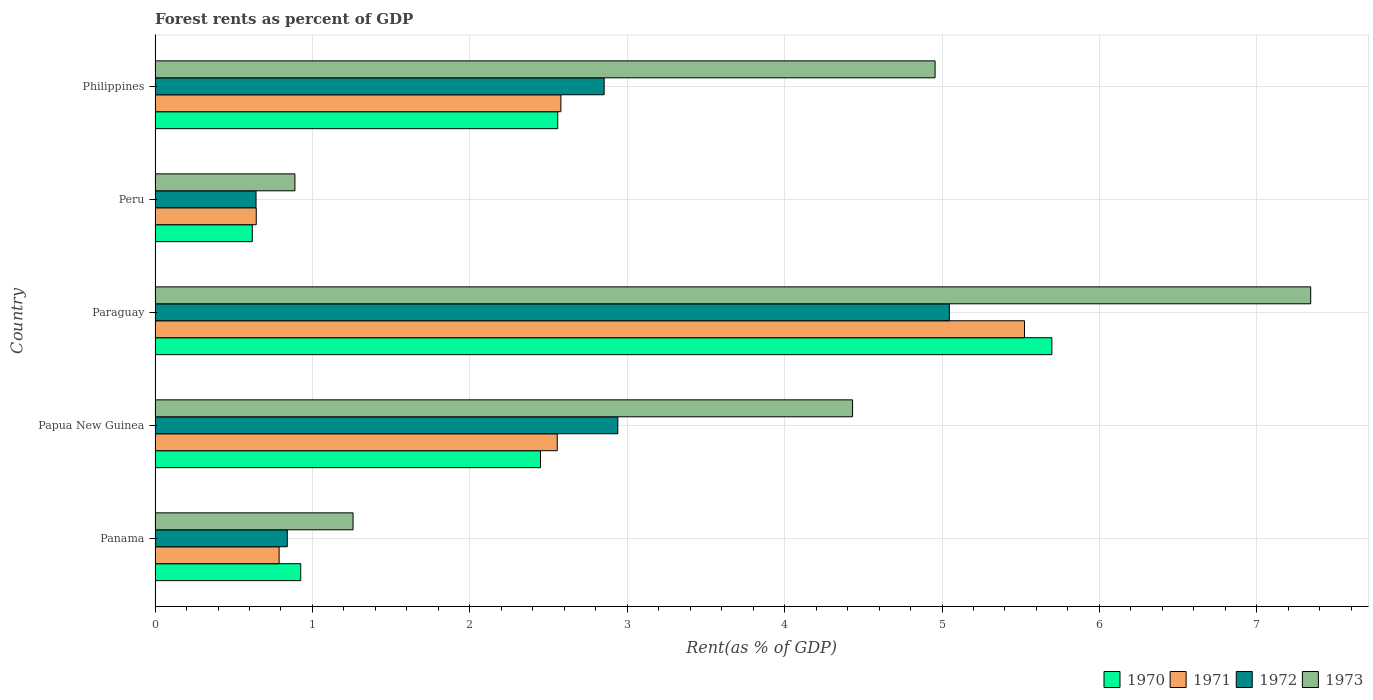How many different coloured bars are there?
Your answer should be very brief. 4. Are the number of bars per tick equal to the number of legend labels?
Offer a very short reply. Yes. How many bars are there on the 3rd tick from the top?
Your answer should be very brief. 4. How many bars are there on the 1st tick from the bottom?
Give a very brief answer. 4. What is the label of the 5th group of bars from the top?
Offer a very short reply. Panama. What is the forest rent in 1972 in Peru?
Provide a succinct answer. 0.64. Across all countries, what is the maximum forest rent in 1970?
Give a very brief answer. 5.7. Across all countries, what is the minimum forest rent in 1972?
Ensure brevity in your answer.  0.64. In which country was the forest rent in 1972 maximum?
Ensure brevity in your answer.  Paraguay. What is the total forest rent in 1971 in the graph?
Give a very brief answer. 12.09. What is the difference between the forest rent in 1970 in Paraguay and that in Peru?
Your answer should be very brief. 5.08. What is the difference between the forest rent in 1972 in Papua New Guinea and the forest rent in 1970 in Philippines?
Your response must be concise. 0.38. What is the average forest rent in 1970 per country?
Your answer should be very brief. 2.45. What is the difference between the forest rent in 1971 and forest rent in 1973 in Papua New Guinea?
Your answer should be compact. -1.88. What is the ratio of the forest rent in 1970 in Papua New Guinea to that in Philippines?
Provide a short and direct response. 0.96. What is the difference between the highest and the second highest forest rent in 1970?
Make the answer very short. 3.14. What is the difference between the highest and the lowest forest rent in 1970?
Give a very brief answer. 5.08. In how many countries, is the forest rent in 1970 greater than the average forest rent in 1970 taken over all countries?
Provide a succinct answer. 2. Is it the case that in every country, the sum of the forest rent in 1971 and forest rent in 1973 is greater than the forest rent in 1972?
Ensure brevity in your answer.  Yes. How many countries are there in the graph?
Provide a short and direct response. 5. How many legend labels are there?
Provide a short and direct response. 4. How are the legend labels stacked?
Make the answer very short. Horizontal. What is the title of the graph?
Your answer should be very brief. Forest rents as percent of GDP. Does "1986" appear as one of the legend labels in the graph?
Your answer should be compact. No. What is the label or title of the X-axis?
Offer a terse response. Rent(as % of GDP). What is the label or title of the Y-axis?
Ensure brevity in your answer.  Country. What is the Rent(as % of GDP) in 1970 in Panama?
Provide a succinct answer. 0.93. What is the Rent(as % of GDP) in 1971 in Panama?
Offer a terse response. 0.79. What is the Rent(as % of GDP) of 1972 in Panama?
Provide a succinct answer. 0.84. What is the Rent(as % of GDP) of 1973 in Panama?
Offer a very short reply. 1.26. What is the Rent(as % of GDP) in 1970 in Papua New Guinea?
Give a very brief answer. 2.45. What is the Rent(as % of GDP) in 1971 in Papua New Guinea?
Give a very brief answer. 2.56. What is the Rent(as % of GDP) in 1972 in Papua New Guinea?
Make the answer very short. 2.94. What is the Rent(as % of GDP) of 1973 in Papua New Guinea?
Offer a very short reply. 4.43. What is the Rent(as % of GDP) in 1970 in Paraguay?
Keep it short and to the point. 5.7. What is the Rent(as % of GDP) in 1971 in Paraguay?
Offer a very short reply. 5.52. What is the Rent(as % of GDP) in 1972 in Paraguay?
Give a very brief answer. 5.05. What is the Rent(as % of GDP) in 1973 in Paraguay?
Offer a very short reply. 7.34. What is the Rent(as % of GDP) in 1970 in Peru?
Your answer should be compact. 0.62. What is the Rent(as % of GDP) of 1971 in Peru?
Ensure brevity in your answer.  0.64. What is the Rent(as % of GDP) in 1972 in Peru?
Your answer should be very brief. 0.64. What is the Rent(as % of GDP) of 1973 in Peru?
Your answer should be very brief. 0.89. What is the Rent(as % of GDP) of 1970 in Philippines?
Keep it short and to the point. 2.56. What is the Rent(as % of GDP) of 1971 in Philippines?
Your answer should be very brief. 2.58. What is the Rent(as % of GDP) of 1972 in Philippines?
Offer a very short reply. 2.85. What is the Rent(as % of GDP) of 1973 in Philippines?
Give a very brief answer. 4.96. Across all countries, what is the maximum Rent(as % of GDP) in 1970?
Offer a terse response. 5.7. Across all countries, what is the maximum Rent(as % of GDP) in 1971?
Your answer should be compact. 5.52. Across all countries, what is the maximum Rent(as % of GDP) in 1972?
Ensure brevity in your answer.  5.05. Across all countries, what is the maximum Rent(as % of GDP) of 1973?
Your response must be concise. 7.34. Across all countries, what is the minimum Rent(as % of GDP) of 1970?
Offer a very short reply. 0.62. Across all countries, what is the minimum Rent(as % of GDP) in 1971?
Your answer should be compact. 0.64. Across all countries, what is the minimum Rent(as % of GDP) in 1972?
Your answer should be compact. 0.64. Across all countries, what is the minimum Rent(as % of GDP) in 1973?
Make the answer very short. 0.89. What is the total Rent(as % of GDP) of 1970 in the graph?
Provide a succinct answer. 12.25. What is the total Rent(as % of GDP) of 1971 in the graph?
Offer a terse response. 12.09. What is the total Rent(as % of GDP) of 1972 in the graph?
Offer a terse response. 12.32. What is the total Rent(as % of GDP) of 1973 in the graph?
Your response must be concise. 18.88. What is the difference between the Rent(as % of GDP) in 1970 in Panama and that in Papua New Guinea?
Provide a succinct answer. -1.52. What is the difference between the Rent(as % of GDP) in 1971 in Panama and that in Papua New Guinea?
Your answer should be compact. -1.77. What is the difference between the Rent(as % of GDP) in 1973 in Panama and that in Papua New Guinea?
Offer a terse response. -3.17. What is the difference between the Rent(as % of GDP) in 1970 in Panama and that in Paraguay?
Make the answer very short. -4.77. What is the difference between the Rent(as % of GDP) in 1971 in Panama and that in Paraguay?
Provide a short and direct response. -4.74. What is the difference between the Rent(as % of GDP) in 1972 in Panama and that in Paraguay?
Ensure brevity in your answer.  -4.21. What is the difference between the Rent(as % of GDP) in 1973 in Panama and that in Paraguay?
Provide a succinct answer. -6.08. What is the difference between the Rent(as % of GDP) in 1970 in Panama and that in Peru?
Provide a short and direct response. 0.31. What is the difference between the Rent(as % of GDP) of 1971 in Panama and that in Peru?
Offer a very short reply. 0.15. What is the difference between the Rent(as % of GDP) of 1972 in Panama and that in Peru?
Keep it short and to the point. 0.2. What is the difference between the Rent(as % of GDP) in 1973 in Panama and that in Peru?
Your response must be concise. 0.37. What is the difference between the Rent(as % of GDP) in 1970 in Panama and that in Philippines?
Keep it short and to the point. -1.63. What is the difference between the Rent(as % of GDP) of 1971 in Panama and that in Philippines?
Your response must be concise. -1.79. What is the difference between the Rent(as % of GDP) in 1972 in Panama and that in Philippines?
Keep it short and to the point. -2.01. What is the difference between the Rent(as % of GDP) in 1973 in Panama and that in Philippines?
Provide a short and direct response. -3.7. What is the difference between the Rent(as % of GDP) in 1970 in Papua New Guinea and that in Paraguay?
Make the answer very short. -3.25. What is the difference between the Rent(as % of GDP) in 1971 in Papua New Guinea and that in Paraguay?
Offer a terse response. -2.97. What is the difference between the Rent(as % of GDP) in 1972 in Papua New Guinea and that in Paraguay?
Your response must be concise. -2.11. What is the difference between the Rent(as % of GDP) of 1973 in Papua New Guinea and that in Paraguay?
Ensure brevity in your answer.  -2.91. What is the difference between the Rent(as % of GDP) in 1970 in Papua New Guinea and that in Peru?
Keep it short and to the point. 1.83. What is the difference between the Rent(as % of GDP) in 1971 in Papua New Guinea and that in Peru?
Your answer should be compact. 1.91. What is the difference between the Rent(as % of GDP) of 1972 in Papua New Guinea and that in Peru?
Keep it short and to the point. 2.3. What is the difference between the Rent(as % of GDP) in 1973 in Papua New Guinea and that in Peru?
Provide a short and direct response. 3.54. What is the difference between the Rent(as % of GDP) in 1970 in Papua New Guinea and that in Philippines?
Your response must be concise. -0.11. What is the difference between the Rent(as % of GDP) of 1971 in Papua New Guinea and that in Philippines?
Your response must be concise. -0.02. What is the difference between the Rent(as % of GDP) of 1972 in Papua New Guinea and that in Philippines?
Provide a short and direct response. 0.09. What is the difference between the Rent(as % of GDP) in 1973 in Papua New Guinea and that in Philippines?
Give a very brief answer. -0.52. What is the difference between the Rent(as % of GDP) in 1970 in Paraguay and that in Peru?
Offer a very short reply. 5.08. What is the difference between the Rent(as % of GDP) of 1971 in Paraguay and that in Peru?
Your answer should be compact. 4.88. What is the difference between the Rent(as % of GDP) in 1972 in Paraguay and that in Peru?
Provide a succinct answer. 4.41. What is the difference between the Rent(as % of GDP) in 1973 in Paraguay and that in Peru?
Provide a short and direct response. 6.45. What is the difference between the Rent(as % of GDP) of 1970 in Paraguay and that in Philippines?
Provide a succinct answer. 3.14. What is the difference between the Rent(as % of GDP) of 1971 in Paraguay and that in Philippines?
Give a very brief answer. 2.95. What is the difference between the Rent(as % of GDP) in 1972 in Paraguay and that in Philippines?
Offer a terse response. 2.19. What is the difference between the Rent(as % of GDP) of 1973 in Paraguay and that in Philippines?
Give a very brief answer. 2.39. What is the difference between the Rent(as % of GDP) of 1970 in Peru and that in Philippines?
Your answer should be compact. -1.94. What is the difference between the Rent(as % of GDP) of 1971 in Peru and that in Philippines?
Your response must be concise. -1.94. What is the difference between the Rent(as % of GDP) of 1972 in Peru and that in Philippines?
Give a very brief answer. -2.21. What is the difference between the Rent(as % of GDP) of 1973 in Peru and that in Philippines?
Your answer should be very brief. -4.07. What is the difference between the Rent(as % of GDP) in 1970 in Panama and the Rent(as % of GDP) in 1971 in Papua New Guinea?
Ensure brevity in your answer.  -1.63. What is the difference between the Rent(as % of GDP) in 1970 in Panama and the Rent(as % of GDP) in 1972 in Papua New Guinea?
Provide a succinct answer. -2.01. What is the difference between the Rent(as % of GDP) of 1970 in Panama and the Rent(as % of GDP) of 1973 in Papua New Guinea?
Your answer should be compact. -3.51. What is the difference between the Rent(as % of GDP) in 1971 in Panama and the Rent(as % of GDP) in 1972 in Papua New Guinea?
Your response must be concise. -2.15. What is the difference between the Rent(as % of GDP) of 1971 in Panama and the Rent(as % of GDP) of 1973 in Papua New Guinea?
Give a very brief answer. -3.64. What is the difference between the Rent(as % of GDP) of 1972 in Panama and the Rent(as % of GDP) of 1973 in Papua New Guinea?
Your response must be concise. -3.59. What is the difference between the Rent(as % of GDP) of 1970 in Panama and the Rent(as % of GDP) of 1971 in Paraguay?
Provide a short and direct response. -4.6. What is the difference between the Rent(as % of GDP) in 1970 in Panama and the Rent(as % of GDP) in 1972 in Paraguay?
Offer a terse response. -4.12. What is the difference between the Rent(as % of GDP) in 1970 in Panama and the Rent(as % of GDP) in 1973 in Paraguay?
Your answer should be compact. -6.42. What is the difference between the Rent(as % of GDP) in 1971 in Panama and the Rent(as % of GDP) in 1972 in Paraguay?
Provide a succinct answer. -4.26. What is the difference between the Rent(as % of GDP) of 1971 in Panama and the Rent(as % of GDP) of 1973 in Paraguay?
Keep it short and to the point. -6.55. What is the difference between the Rent(as % of GDP) of 1972 in Panama and the Rent(as % of GDP) of 1973 in Paraguay?
Give a very brief answer. -6.5. What is the difference between the Rent(as % of GDP) in 1970 in Panama and the Rent(as % of GDP) in 1971 in Peru?
Offer a terse response. 0.28. What is the difference between the Rent(as % of GDP) of 1970 in Panama and the Rent(as % of GDP) of 1972 in Peru?
Offer a terse response. 0.28. What is the difference between the Rent(as % of GDP) of 1970 in Panama and the Rent(as % of GDP) of 1973 in Peru?
Provide a short and direct response. 0.04. What is the difference between the Rent(as % of GDP) in 1971 in Panama and the Rent(as % of GDP) in 1972 in Peru?
Give a very brief answer. 0.15. What is the difference between the Rent(as % of GDP) of 1971 in Panama and the Rent(as % of GDP) of 1973 in Peru?
Give a very brief answer. -0.1. What is the difference between the Rent(as % of GDP) in 1972 in Panama and the Rent(as % of GDP) in 1973 in Peru?
Give a very brief answer. -0.05. What is the difference between the Rent(as % of GDP) of 1970 in Panama and the Rent(as % of GDP) of 1971 in Philippines?
Provide a short and direct response. -1.65. What is the difference between the Rent(as % of GDP) in 1970 in Panama and the Rent(as % of GDP) in 1972 in Philippines?
Make the answer very short. -1.93. What is the difference between the Rent(as % of GDP) of 1970 in Panama and the Rent(as % of GDP) of 1973 in Philippines?
Your response must be concise. -4.03. What is the difference between the Rent(as % of GDP) in 1971 in Panama and the Rent(as % of GDP) in 1972 in Philippines?
Keep it short and to the point. -2.07. What is the difference between the Rent(as % of GDP) in 1971 in Panama and the Rent(as % of GDP) in 1973 in Philippines?
Your answer should be compact. -4.17. What is the difference between the Rent(as % of GDP) in 1972 in Panama and the Rent(as % of GDP) in 1973 in Philippines?
Provide a succinct answer. -4.12. What is the difference between the Rent(as % of GDP) in 1970 in Papua New Guinea and the Rent(as % of GDP) in 1971 in Paraguay?
Your answer should be compact. -3.08. What is the difference between the Rent(as % of GDP) of 1970 in Papua New Guinea and the Rent(as % of GDP) of 1972 in Paraguay?
Your response must be concise. -2.6. What is the difference between the Rent(as % of GDP) of 1970 in Papua New Guinea and the Rent(as % of GDP) of 1973 in Paraguay?
Your answer should be compact. -4.89. What is the difference between the Rent(as % of GDP) in 1971 in Papua New Guinea and the Rent(as % of GDP) in 1972 in Paraguay?
Your answer should be compact. -2.49. What is the difference between the Rent(as % of GDP) of 1971 in Papua New Guinea and the Rent(as % of GDP) of 1973 in Paraguay?
Offer a very short reply. -4.79. What is the difference between the Rent(as % of GDP) of 1972 in Papua New Guinea and the Rent(as % of GDP) of 1973 in Paraguay?
Ensure brevity in your answer.  -4.4. What is the difference between the Rent(as % of GDP) in 1970 in Papua New Guinea and the Rent(as % of GDP) in 1971 in Peru?
Your answer should be very brief. 1.81. What is the difference between the Rent(as % of GDP) in 1970 in Papua New Guinea and the Rent(as % of GDP) in 1972 in Peru?
Provide a succinct answer. 1.81. What is the difference between the Rent(as % of GDP) of 1970 in Papua New Guinea and the Rent(as % of GDP) of 1973 in Peru?
Offer a very short reply. 1.56. What is the difference between the Rent(as % of GDP) of 1971 in Papua New Guinea and the Rent(as % of GDP) of 1972 in Peru?
Ensure brevity in your answer.  1.91. What is the difference between the Rent(as % of GDP) in 1972 in Papua New Guinea and the Rent(as % of GDP) in 1973 in Peru?
Provide a short and direct response. 2.05. What is the difference between the Rent(as % of GDP) in 1970 in Papua New Guinea and the Rent(as % of GDP) in 1971 in Philippines?
Your answer should be very brief. -0.13. What is the difference between the Rent(as % of GDP) in 1970 in Papua New Guinea and the Rent(as % of GDP) in 1972 in Philippines?
Provide a short and direct response. -0.4. What is the difference between the Rent(as % of GDP) of 1970 in Papua New Guinea and the Rent(as % of GDP) of 1973 in Philippines?
Give a very brief answer. -2.51. What is the difference between the Rent(as % of GDP) in 1971 in Papua New Guinea and the Rent(as % of GDP) in 1972 in Philippines?
Make the answer very short. -0.3. What is the difference between the Rent(as % of GDP) of 1971 in Papua New Guinea and the Rent(as % of GDP) of 1973 in Philippines?
Keep it short and to the point. -2.4. What is the difference between the Rent(as % of GDP) in 1972 in Papua New Guinea and the Rent(as % of GDP) in 1973 in Philippines?
Offer a very short reply. -2.02. What is the difference between the Rent(as % of GDP) in 1970 in Paraguay and the Rent(as % of GDP) in 1971 in Peru?
Offer a terse response. 5.06. What is the difference between the Rent(as % of GDP) of 1970 in Paraguay and the Rent(as % of GDP) of 1972 in Peru?
Ensure brevity in your answer.  5.06. What is the difference between the Rent(as % of GDP) in 1970 in Paraguay and the Rent(as % of GDP) in 1973 in Peru?
Your answer should be very brief. 4.81. What is the difference between the Rent(as % of GDP) in 1971 in Paraguay and the Rent(as % of GDP) in 1972 in Peru?
Make the answer very short. 4.88. What is the difference between the Rent(as % of GDP) of 1971 in Paraguay and the Rent(as % of GDP) of 1973 in Peru?
Provide a succinct answer. 4.64. What is the difference between the Rent(as % of GDP) in 1972 in Paraguay and the Rent(as % of GDP) in 1973 in Peru?
Give a very brief answer. 4.16. What is the difference between the Rent(as % of GDP) of 1970 in Paraguay and the Rent(as % of GDP) of 1971 in Philippines?
Make the answer very short. 3.12. What is the difference between the Rent(as % of GDP) of 1970 in Paraguay and the Rent(as % of GDP) of 1972 in Philippines?
Make the answer very short. 2.84. What is the difference between the Rent(as % of GDP) in 1970 in Paraguay and the Rent(as % of GDP) in 1973 in Philippines?
Your response must be concise. 0.74. What is the difference between the Rent(as % of GDP) of 1971 in Paraguay and the Rent(as % of GDP) of 1972 in Philippines?
Provide a succinct answer. 2.67. What is the difference between the Rent(as % of GDP) in 1971 in Paraguay and the Rent(as % of GDP) in 1973 in Philippines?
Your answer should be compact. 0.57. What is the difference between the Rent(as % of GDP) of 1972 in Paraguay and the Rent(as % of GDP) of 1973 in Philippines?
Provide a succinct answer. 0.09. What is the difference between the Rent(as % of GDP) of 1970 in Peru and the Rent(as % of GDP) of 1971 in Philippines?
Your response must be concise. -1.96. What is the difference between the Rent(as % of GDP) of 1970 in Peru and the Rent(as % of GDP) of 1972 in Philippines?
Offer a very short reply. -2.24. What is the difference between the Rent(as % of GDP) in 1970 in Peru and the Rent(as % of GDP) in 1973 in Philippines?
Provide a succinct answer. -4.34. What is the difference between the Rent(as % of GDP) in 1971 in Peru and the Rent(as % of GDP) in 1972 in Philippines?
Keep it short and to the point. -2.21. What is the difference between the Rent(as % of GDP) of 1971 in Peru and the Rent(as % of GDP) of 1973 in Philippines?
Your answer should be compact. -4.31. What is the difference between the Rent(as % of GDP) of 1972 in Peru and the Rent(as % of GDP) of 1973 in Philippines?
Your answer should be very brief. -4.31. What is the average Rent(as % of GDP) of 1970 per country?
Offer a very short reply. 2.45. What is the average Rent(as % of GDP) of 1971 per country?
Your answer should be very brief. 2.42. What is the average Rent(as % of GDP) of 1972 per country?
Offer a terse response. 2.46. What is the average Rent(as % of GDP) in 1973 per country?
Ensure brevity in your answer.  3.78. What is the difference between the Rent(as % of GDP) in 1970 and Rent(as % of GDP) in 1971 in Panama?
Provide a succinct answer. 0.14. What is the difference between the Rent(as % of GDP) of 1970 and Rent(as % of GDP) of 1972 in Panama?
Provide a succinct answer. 0.09. What is the difference between the Rent(as % of GDP) of 1970 and Rent(as % of GDP) of 1973 in Panama?
Provide a short and direct response. -0.33. What is the difference between the Rent(as % of GDP) of 1971 and Rent(as % of GDP) of 1972 in Panama?
Make the answer very short. -0.05. What is the difference between the Rent(as % of GDP) of 1971 and Rent(as % of GDP) of 1973 in Panama?
Offer a terse response. -0.47. What is the difference between the Rent(as % of GDP) of 1972 and Rent(as % of GDP) of 1973 in Panama?
Offer a terse response. -0.42. What is the difference between the Rent(as % of GDP) of 1970 and Rent(as % of GDP) of 1971 in Papua New Guinea?
Keep it short and to the point. -0.11. What is the difference between the Rent(as % of GDP) in 1970 and Rent(as % of GDP) in 1972 in Papua New Guinea?
Your response must be concise. -0.49. What is the difference between the Rent(as % of GDP) in 1970 and Rent(as % of GDP) in 1973 in Papua New Guinea?
Provide a short and direct response. -1.98. What is the difference between the Rent(as % of GDP) in 1971 and Rent(as % of GDP) in 1972 in Papua New Guinea?
Make the answer very short. -0.38. What is the difference between the Rent(as % of GDP) of 1971 and Rent(as % of GDP) of 1973 in Papua New Guinea?
Ensure brevity in your answer.  -1.88. What is the difference between the Rent(as % of GDP) in 1972 and Rent(as % of GDP) in 1973 in Papua New Guinea?
Ensure brevity in your answer.  -1.49. What is the difference between the Rent(as % of GDP) in 1970 and Rent(as % of GDP) in 1971 in Paraguay?
Offer a terse response. 0.17. What is the difference between the Rent(as % of GDP) of 1970 and Rent(as % of GDP) of 1972 in Paraguay?
Ensure brevity in your answer.  0.65. What is the difference between the Rent(as % of GDP) in 1970 and Rent(as % of GDP) in 1973 in Paraguay?
Ensure brevity in your answer.  -1.64. What is the difference between the Rent(as % of GDP) of 1971 and Rent(as % of GDP) of 1972 in Paraguay?
Give a very brief answer. 0.48. What is the difference between the Rent(as % of GDP) in 1971 and Rent(as % of GDP) in 1973 in Paraguay?
Ensure brevity in your answer.  -1.82. What is the difference between the Rent(as % of GDP) in 1972 and Rent(as % of GDP) in 1973 in Paraguay?
Keep it short and to the point. -2.3. What is the difference between the Rent(as % of GDP) of 1970 and Rent(as % of GDP) of 1971 in Peru?
Provide a short and direct response. -0.03. What is the difference between the Rent(as % of GDP) in 1970 and Rent(as % of GDP) in 1972 in Peru?
Give a very brief answer. -0.02. What is the difference between the Rent(as % of GDP) of 1970 and Rent(as % of GDP) of 1973 in Peru?
Provide a succinct answer. -0.27. What is the difference between the Rent(as % of GDP) in 1971 and Rent(as % of GDP) in 1972 in Peru?
Provide a short and direct response. 0. What is the difference between the Rent(as % of GDP) of 1971 and Rent(as % of GDP) of 1973 in Peru?
Give a very brief answer. -0.25. What is the difference between the Rent(as % of GDP) in 1972 and Rent(as % of GDP) in 1973 in Peru?
Ensure brevity in your answer.  -0.25. What is the difference between the Rent(as % of GDP) of 1970 and Rent(as % of GDP) of 1971 in Philippines?
Give a very brief answer. -0.02. What is the difference between the Rent(as % of GDP) in 1970 and Rent(as % of GDP) in 1972 in Philippines?
Your answer should be very brief. -0.29. What is the difference between the Rent(as % of GDP) of 1970 and Rent(as % of GDP) of 1973 in Philippines?
Make the answer very short. -2.4. What is the difference between the Rent(as % of GDP) of 1971 and Rent(as % of GDP) of 1972 in Philippines?
Keep it short and to the point. -0.27. What is the difference between the Rent(as % of GDP) of 1971 and Rent(as % of GDP) of 1973 in Philippines?
Your answer should be compact. -2.38. What is the difference between the Rent(as % of GDP) in 1972 and Rent(as % of GDP) in 1973 in Philippines?
Offer a very short reply. -2.1. What is the ratio of the Rent(as % of GDP) in 1970 in Panama to that in Papua New Guinea?
Provide a succinct answer. 0.38. What is the ratio of the Rent(as % of GDP) of 1971 in Panama to that in Papua New Guinea?
Keep it short and to the point. 0.31. What is the ratio of the Rent(as % of GDP) in 1972 in Panama to that in Papua New Guinea?
Give a very brief answer. 0.29. What is the ratio of the Rent(as % of GDP) in 1973 in Panama to that in Papua New Guinea?
Your answer should be compact. 0.28. What is the ratio of the Rent(as % of GDP) of 1970 in Panama to that in Paraguay?
Provide a short and direct response. 0.16. What is the ratio of the Rent(as % of GDP) of 1971 in Panama to that in Paraguay?
Your response must be concise. 0.14. What is the ratio of the Rent(as % of GDP) in 1972 in Panama to that in Paraguay?
Provide a short and direct response. 0.17. What is the ratio of the Rent(as % of GDP) of 1973 in Panama to that in Paraguay?
Offer a terse response. 0.17. What is the ratio of the Rent(as % of GDP) in 1970 in Panama to that in Peru?
Offer a terse response. 1.5. What is the ratio of the Rent(as % of GDP) in 1971 in Panama to that in Peru?
Offer a terse response. 1.23. What is the ratio of the Rent(as % of GDP) of 1972 in Panama to that in Peru?
Provide a succinct answer. 1.31. What is the ratio of the Rent(as % of GDP) of 1973 in Panama to that in Peru?
Make the answer very short. 1.42. What is the ratio of the Rent(as % of GDP) in 1970 in Panama to that in Philippines?
Provide a short and direct response. 0.36. What is the ratio of the Rent(as % of GDP) of 1971 in Panama to that in Philippines?
Your response must be concise. 0.31. What is the ratio of the Rent(as % of GDP) of 1972 in Panama to that in Philippines?
Your answer should be very brief. 0.29. What is the ratio of the Rent(as % of GDP) in 1973 in Panama to that in Philippines?
Make the answer very short. 0.25. What is the ratio of the Rent(as % of GDP) in 1970 in Papua New Guinea to that in Paraguay?
Make the answer very short. 0.43. What is the ratio of the Rent(as % of GDP) in 1971 in Papua New Guinea to that in Paraguay?
Provide a succinct answer. 0.46. What is the ratio of the Rent(as % of GDP) of 1972 in Papua New Guinea to that in Paraguay?
Make the answer very short. 0.58. What is the ratio of the Rent(as % of GDP) in 1973 in Papua New Guinea to that in Paraguay?
Keep it short and to the point. 0.6. What is the ratio of the Rent(as % of GDP) in 1970 in Papua New Guinea to that in Peru?
Your response must be concise. 3.96. What is the ratio of the Rent(as % of GDP) of 1971 in Papua New Guinea to that in Peru?
Your answer should be compact. 3.97. What is the ratio of the Rent(as % of GDP) of 1972 in Papua New Guinea to that in Peru?
Ensure brevity in your answer.  4.58. What is the ratio of the Rent(as % of GDP) of 1973 in Papua New Guinea to that in Peru?
Provide a succinct answer. 4.99. What is the ratio of the Rent(as % of GDP) in 1970 in Papua New Guinea to that in Philippines?
Keep it short and to the point. 0.96. What is the ratio of the Rent(as % of GDP) in 1971 in Papua New Guinea to that in Philippines?
Offer a very short reply. 0.99. What is the ratio of the Rent(as % of GDP) of 1972 in Papua New Guinea to that in Philippines?
Ensure brevity in your answer.  1.03. What is the ratio of the Rent(as % of GDP) of 1973 in Papua New Guinea to that in Philippines?
Provide a short and direct response. 0.89. What is the ratio of the Rent(as % of GDP) in 1970 in Paraguay to that in Peru?
Make the answer very short. 9.23. What is the ratio of the Rent(as % of GDP) in 1971 in Paraguay to that in Peru?
Give a very brief answer. 8.59. What is the ratio of the Rent(as % of GDP) in 1972 in Paraguay to that in Peru?
Your answer should be compact. 7.87. What is the ratio of the Rent(as % of GDP) of 1973 in Paraguay to that in Peru?
Provide a short and direct response. 8.26. What is the ratio of the Rent(as % of GDP) in 1970 in Paraguay to that in Philippines?
Offer a very short reply. 2.23. What is the ratio of the Rent(as % of GDP) in 1971 in Paraguay to that in Philippines?
Give a very brief answer. 2.14. What is the ratio of the Rent(as % of GDP) in 1972 in Paraguay to that in Philippines?
Your answer should be compact. 1.77. What is the ratio of the Rent(as % of GDP) of 1973 in Paraguay to that in Philippines?
Your response must be concise. 1.48. What is the ratio of the Rent(as % of GDP) in 1970 in Peru to that in Philippines?
Make the answer very short. 0.24. What is the ratio of the Rent(as % of GDP) of 1971 in Peru to that in Philippines?
Provide a short and direct response. 0.25. What is the ratio of the Rent(as % of GDP) in 1972 in Peru to that in Philippines?
Give a very brief answer. 0.22. What is the ratio of the Rent(as % of GDP) of 1973 in Peru to that in Philippines?
Ensure brevity in your answer.  0.18. What is the difference between the highest and the second highest Rent(as % of GDP) of 1970?
Your answer should be compact. 3.14. What is the difference between the highest and the second highest Rent(as % of GDP) in 1971?
Ensure brevity in your answer.  2.95. What is the difference between the highest and the second highest Rent(as % of GDP) in 1972?
Offer a very short reply. 2.11. What is the difference between the highest and the second highest Rent(as % of GDP) in 1973?
Provide a short and direct response. 2.39. What is the difference between the highest and the lowest Rent(as % of GDP) of 1970?
Provide a short and direct response. 5.08. What is the difference between the highest and the lowest Rent(as % of GDP) of 1971?
Offer a terse response. 4.88. What is the difference between the highest and the lowest Rent(as % of GDP) in 1972?
Your answer should be very brief. 4.41. What is the difference between the highest and the lowest Rent(as % of GDP) of 1973?
Make the answer very short. 6.45. 